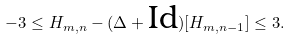Convert formula to latex. <formula><loc_0><loc_0><loc_500><loc_500>- 3 \leq H _ { m , n } - ( \Delta + \text {Id} ) [ H _ { m , n - 1 } ] \leq 3 .</formula> 